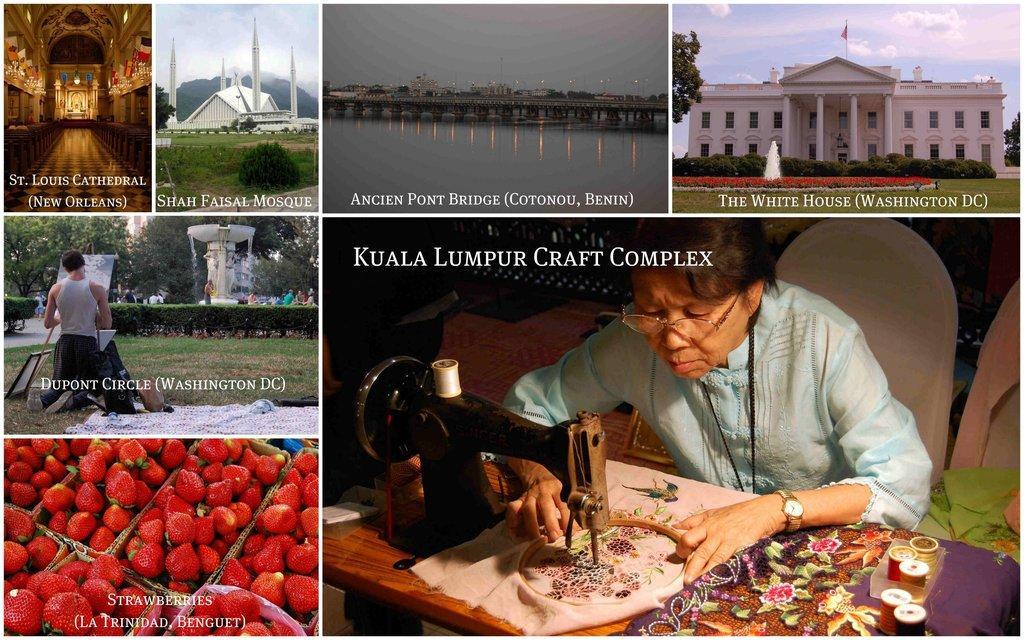Please provide a concise description of this image. As we can see in the image there is a building, sky, water, grass, sewing machine, strawberries, trees and on the right side there is a person sitting on chair. 